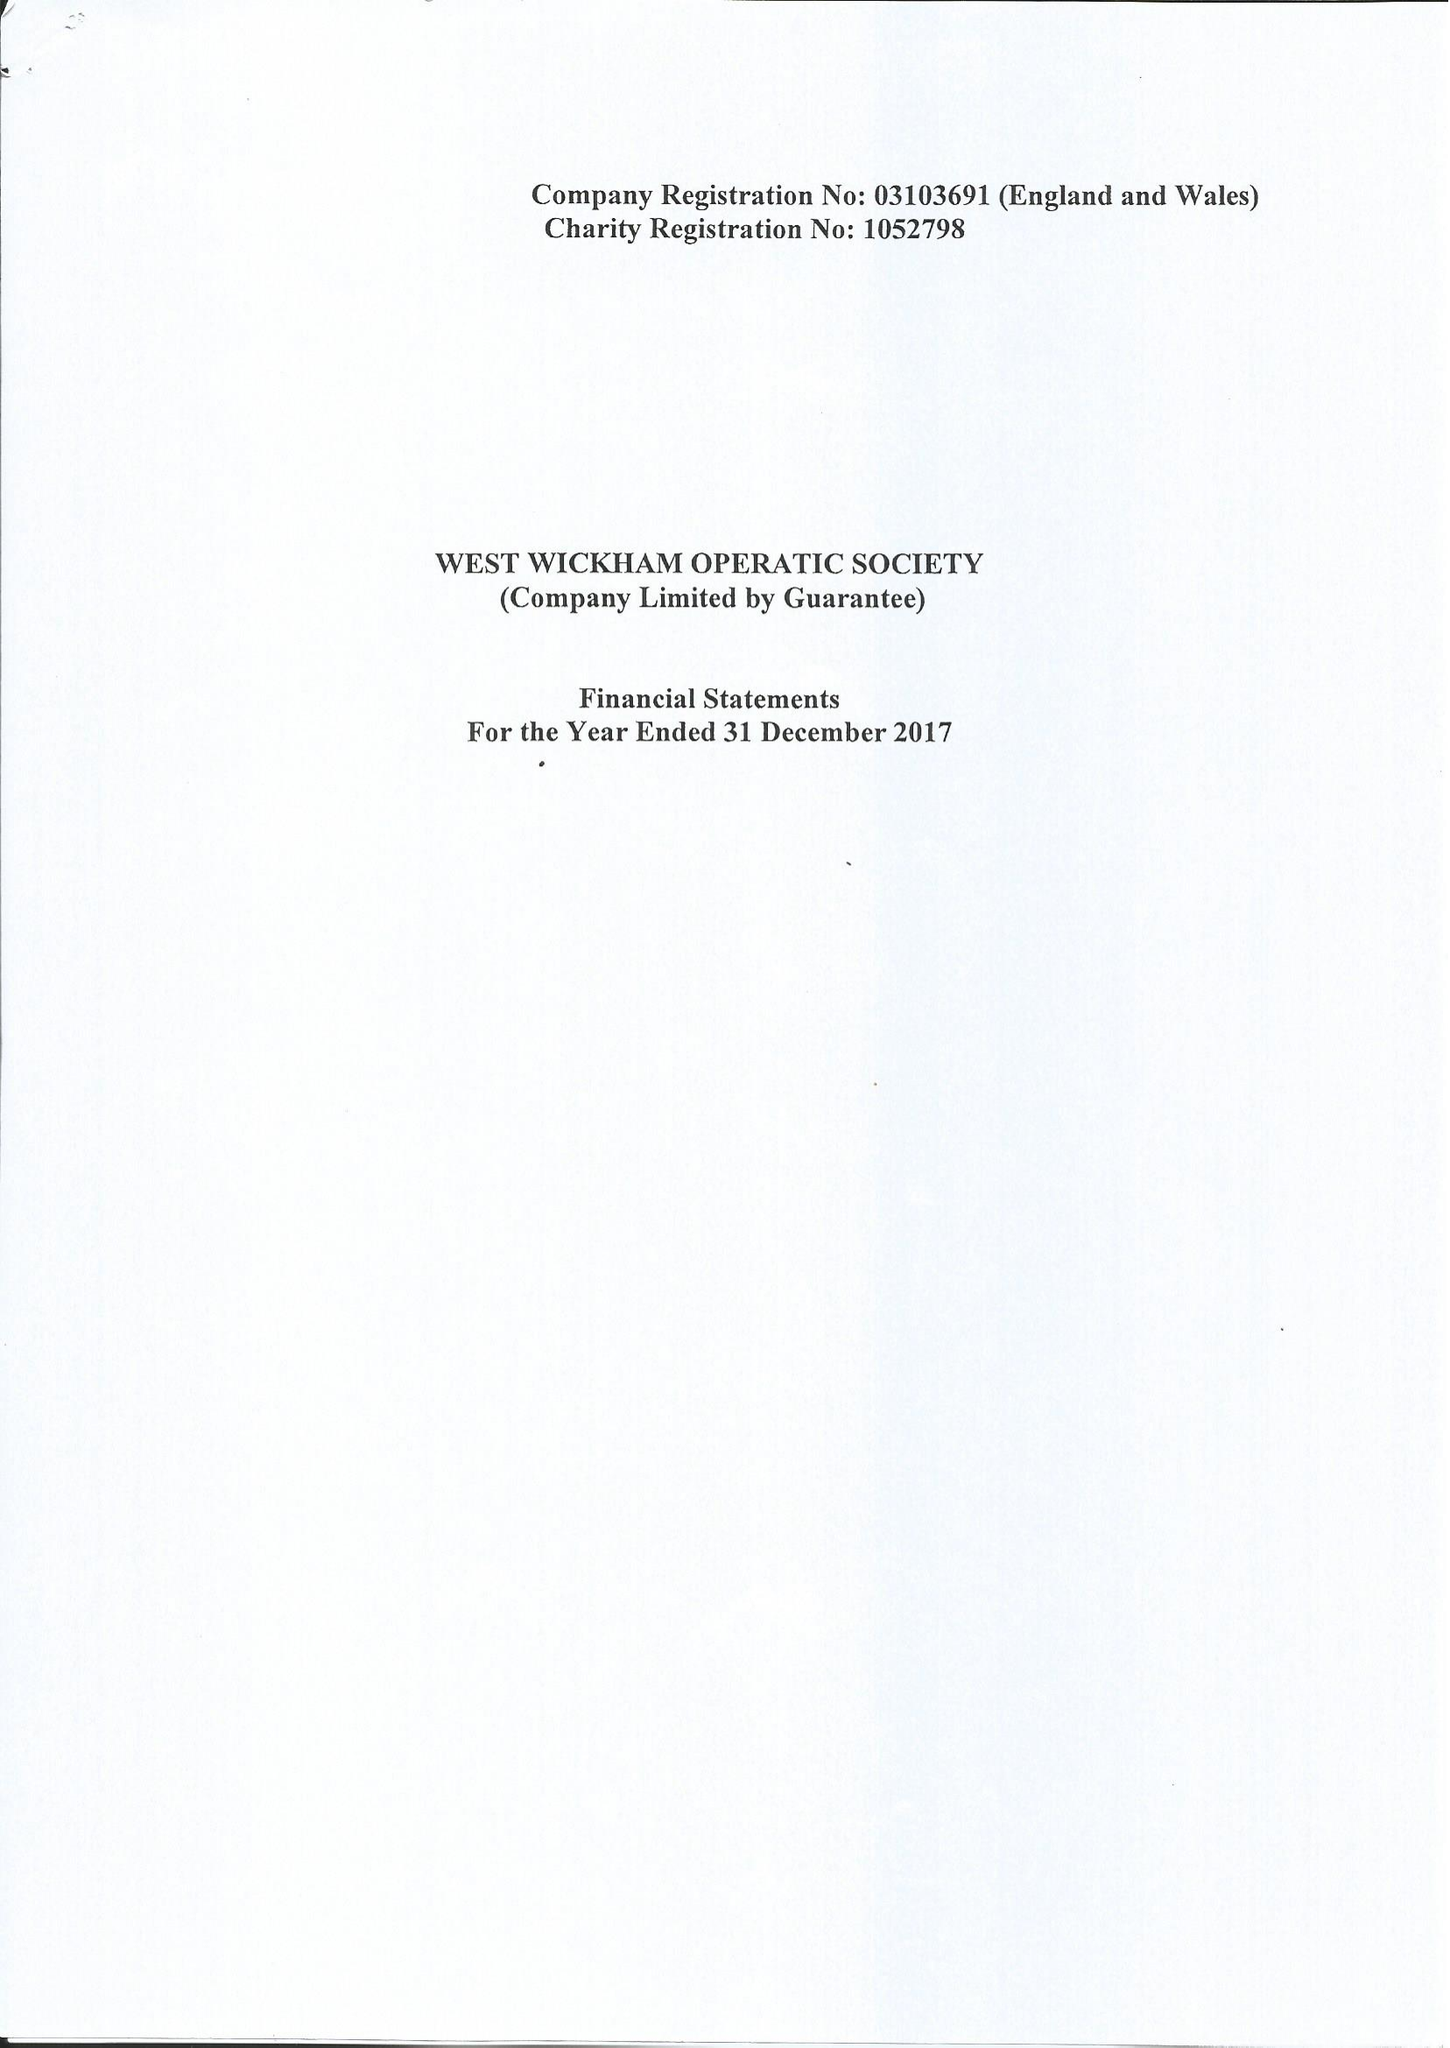What is the value for the charity_number?
Answer the question using a single word or phrase. 1052798 